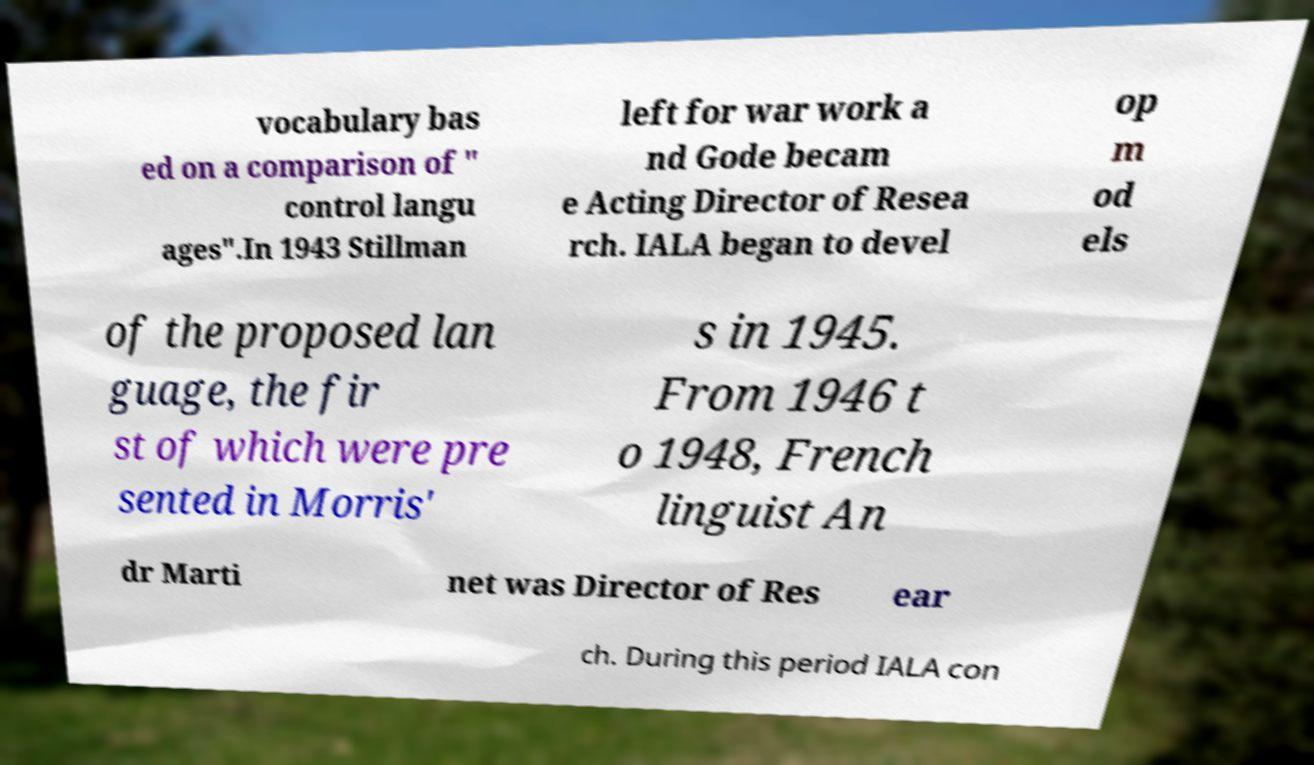Could you assist in decoding the text presented in this image and type it out clearly? vocabulary bas ed on a comparison of " control langu ages".In 1943 Stillman left for war work a nd Gode becam e Acting Director of Resea rch. IALA began to devel op m od els of the proposed lan guage, the fir st of which were pre sented in Morris' s in 1945. From 1946 t o 1948, French linguist An dr Marti net was Director of Res ear ch. During this period IALA con 